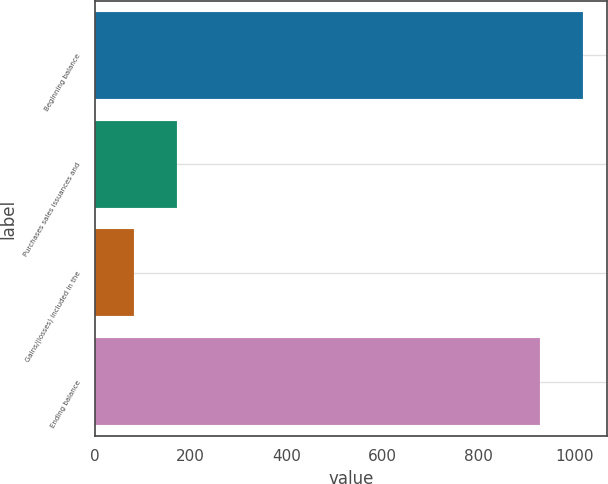<chart> <loc_0><loc_0><loc_500><loc_500><bar_chart><fcel>Beginning balance<fcel>Purchases sales issuances and<fcel>Gains/(losses) included in the<fcel>Ending balance<nl><fcel>1018.27<fcel>170.27<fcel>81.1<fcel>929.1<nl></chart> 